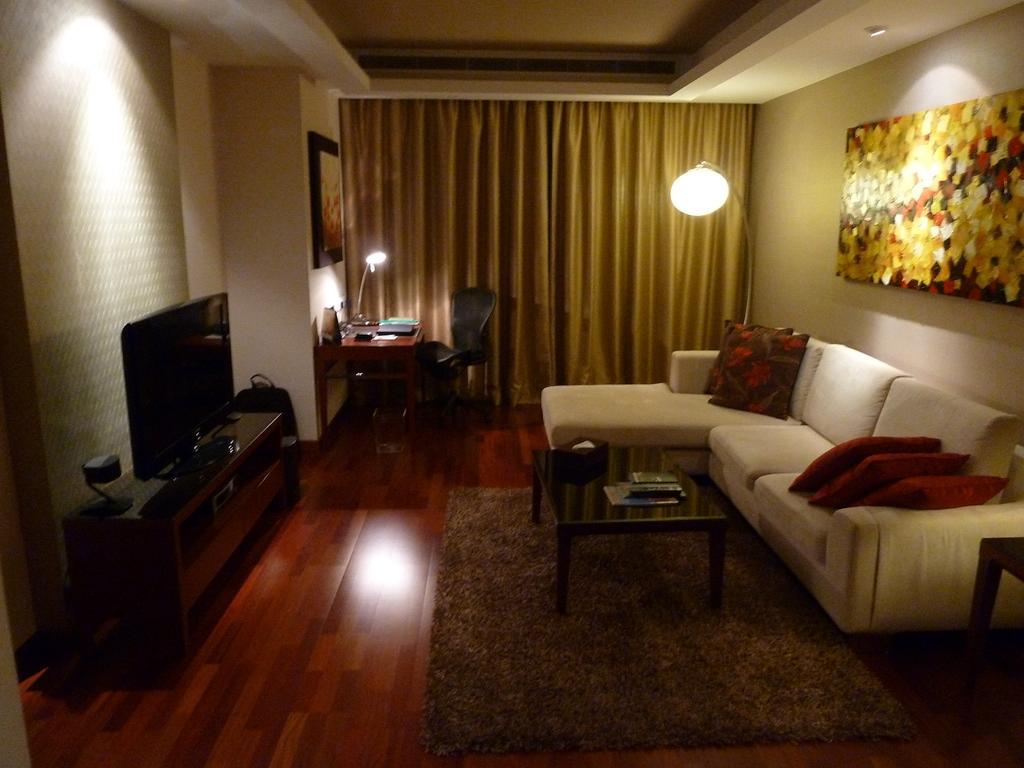Can you describe this image briefly? A living room is shown in the picture. There is a sofa,a table on a mat,a TV on long cupboard,table with a chair and a curtain to cover a window. 